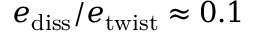<formula> <loc_0><loc_0><loc_500><loc_500>e _ { d i s s } / e _ { t w i s t } \approx 0 . 1</formula> 